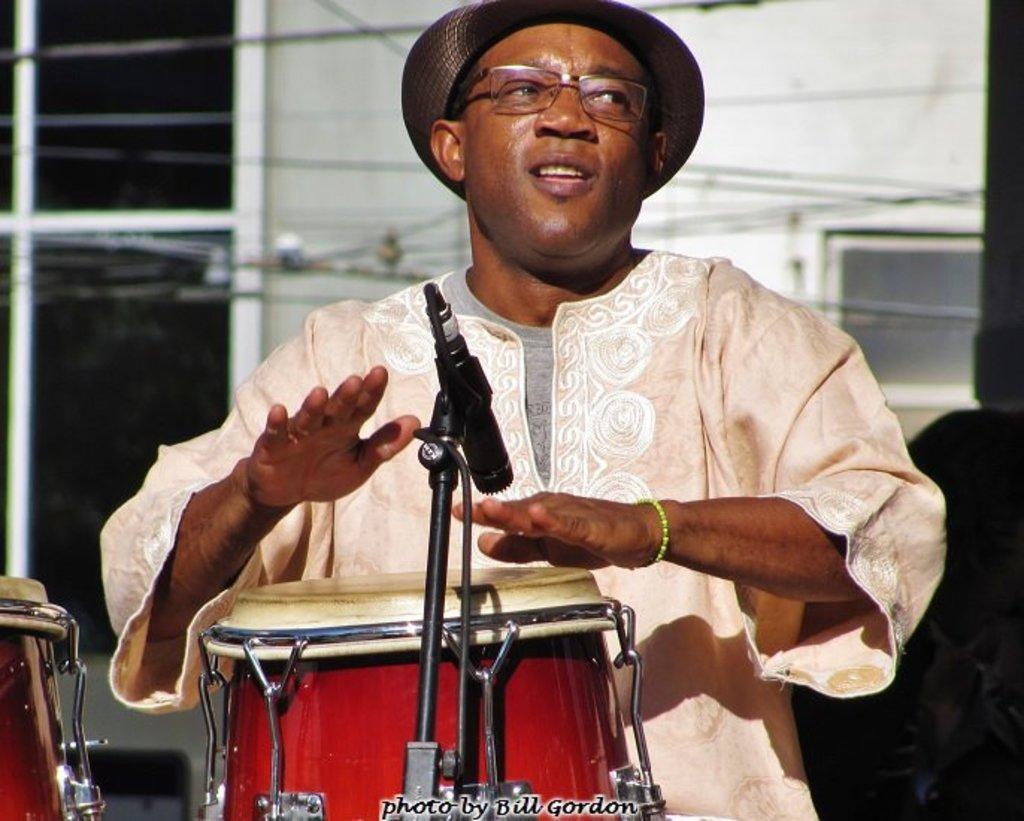In one or two sentences, can you explain what this image depicts? This picture shows a man playing drums with the help of a microphone. 